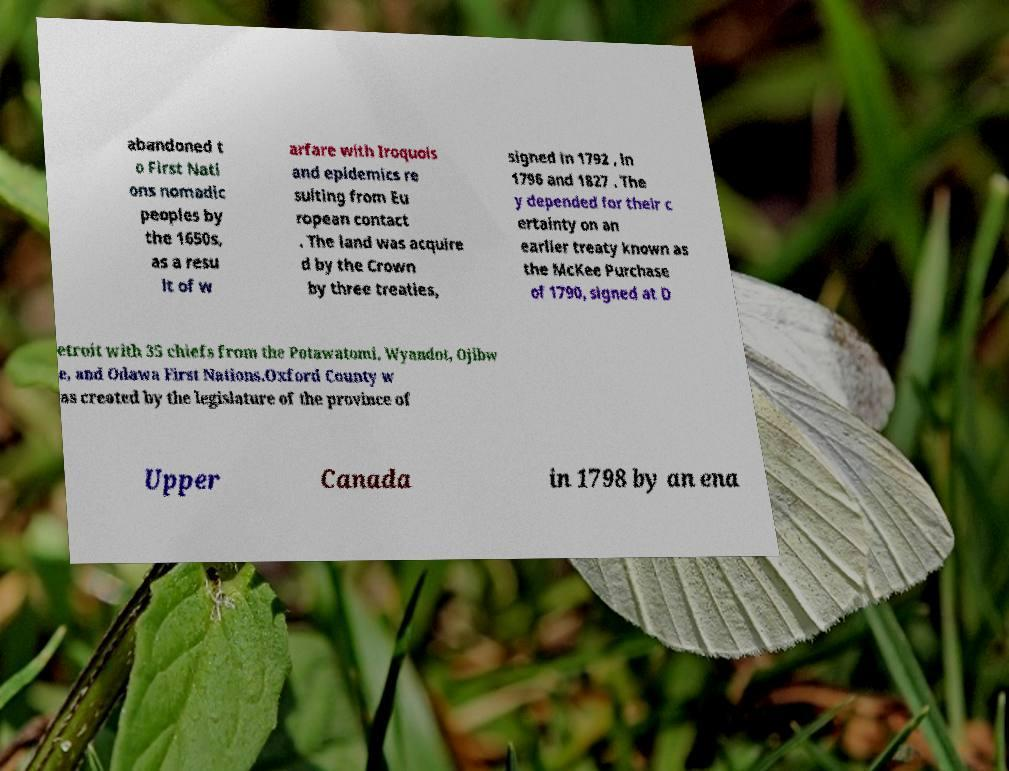Can you read and provide the text displayed in the image?This photo seems to have some interesting text. Can you extract and type it out for me? abandoned t o First Nati ons nomadic peoples by the 1650s, as a resu lt of w arfare with Iroquois and epidemics re sulting from Eu ropean contact . The land was acquire d by the Crown by three treaties, signed in 1792 , in 1796 and 1827 . The y depended for their c ertainty on an earlier treaty known as the McKee Purchase of 1790, signed at D etroit with 35 chiefs from the Potawatomi, Wyandot, Ojibw e, and Odawa First Nations.Oxford County w as created by the legislature of the province of Upper Canada in 1798 by an ena 